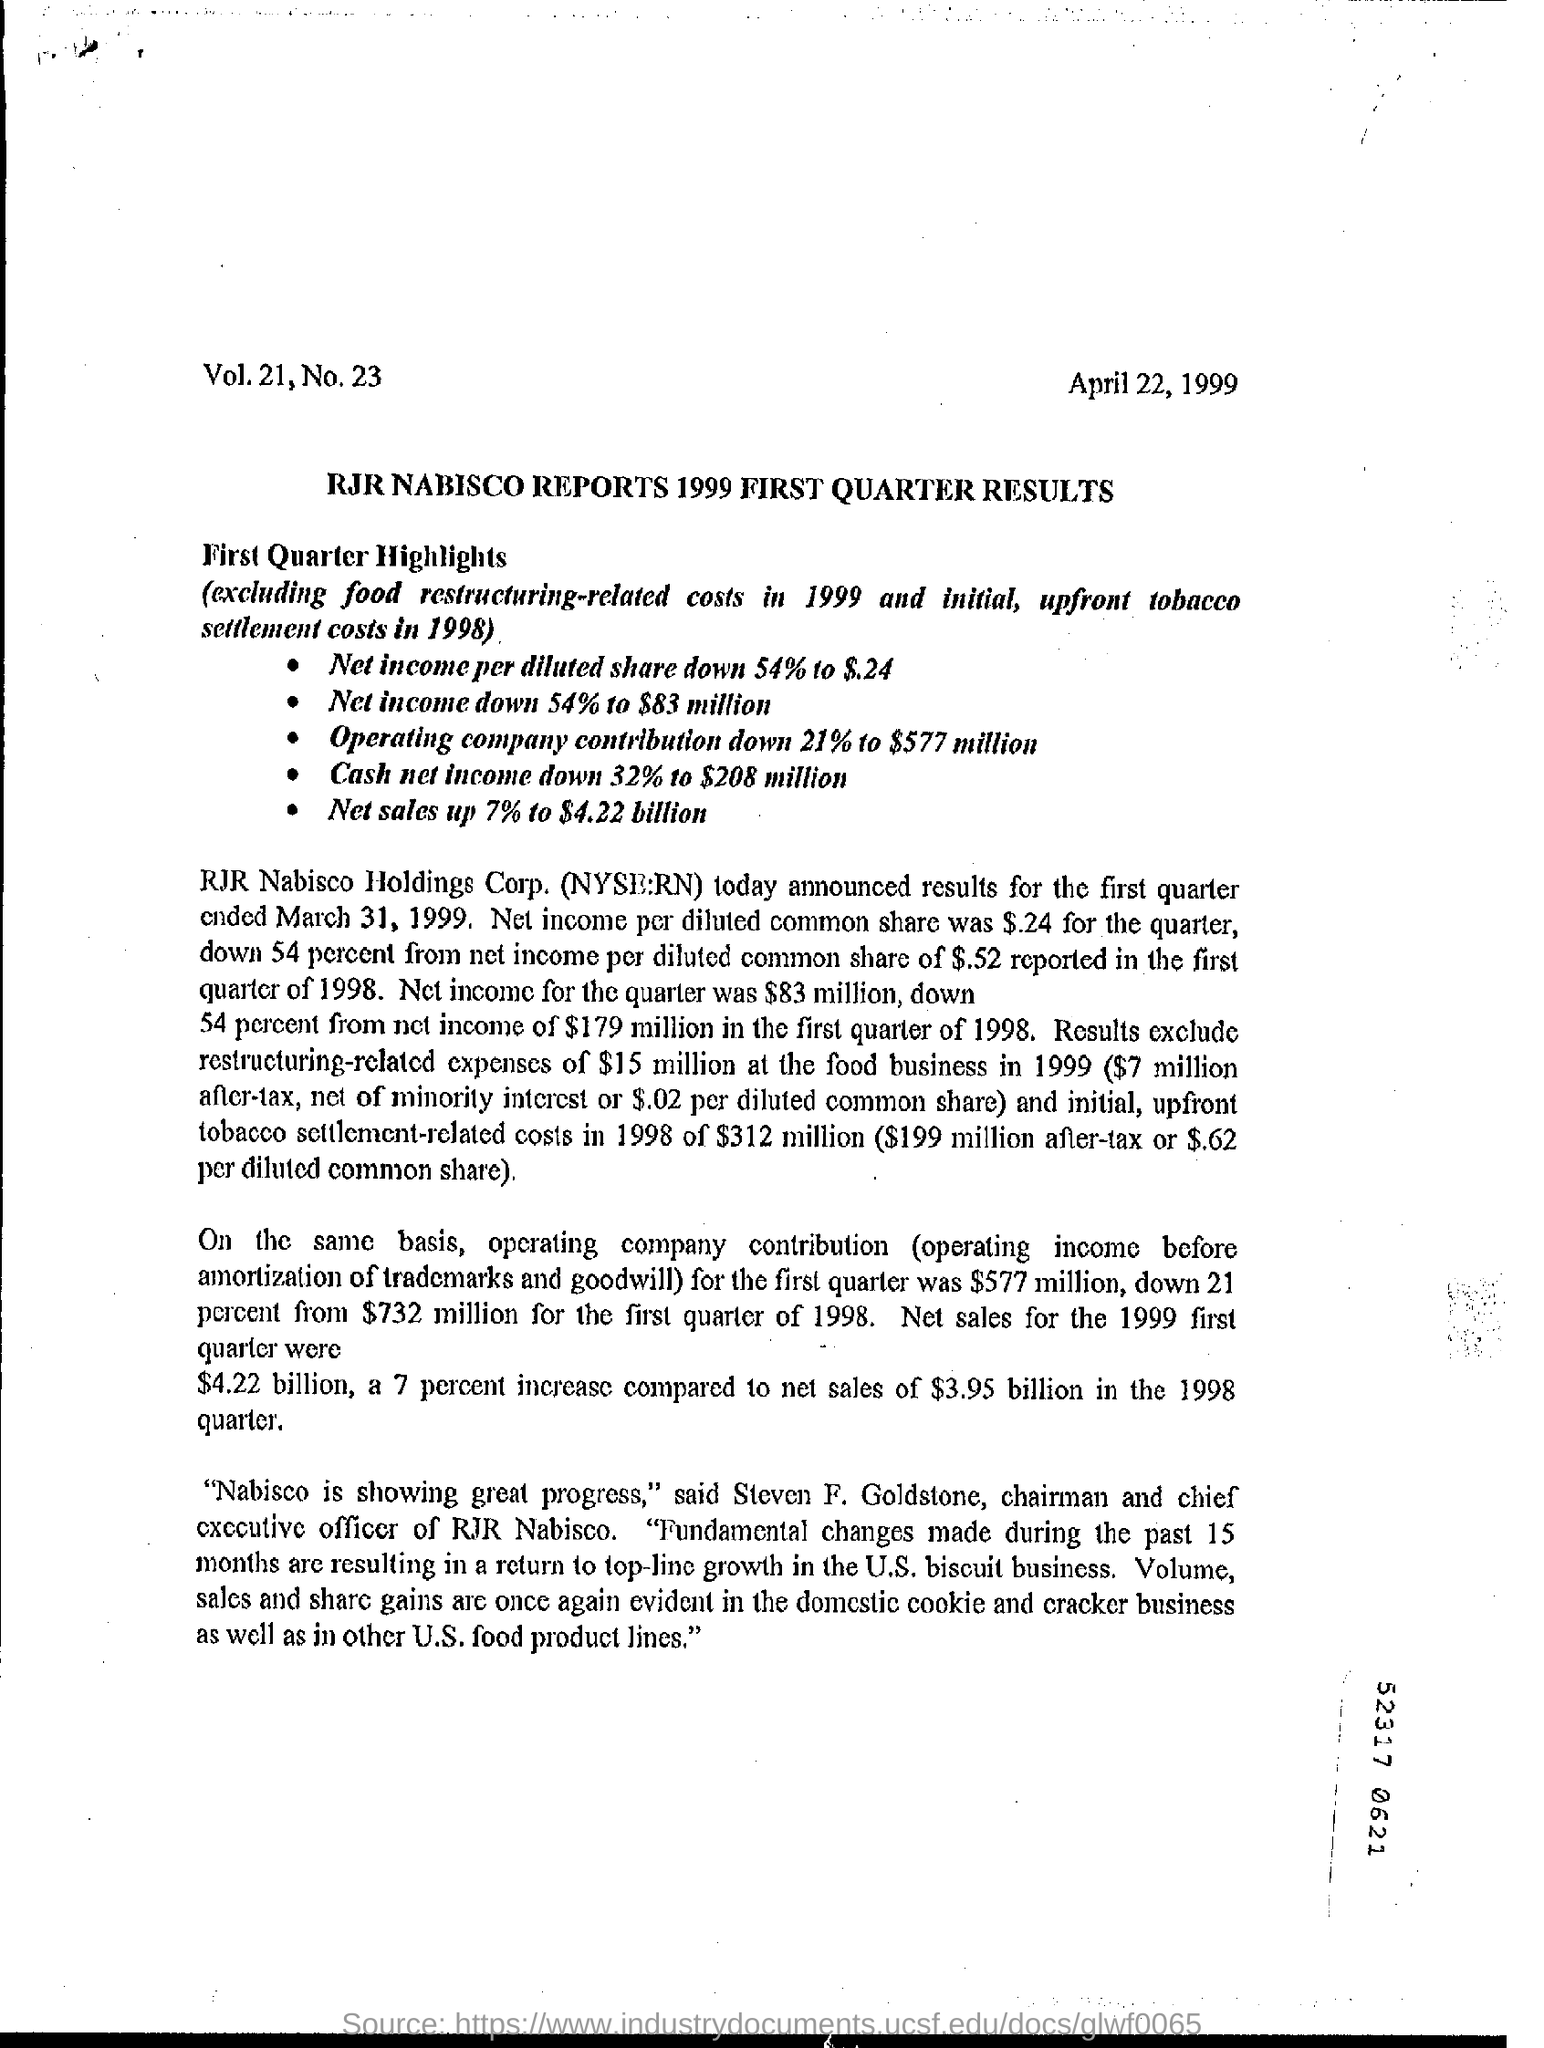Outline some significant characteristics in this image. The net sales for the 1999 first quarter were $4.22 billion. The date mentioned in this document is April 22, 1999. Steven F. Goldstone is the chairman and chief executive officer of RJR Nabisco. 